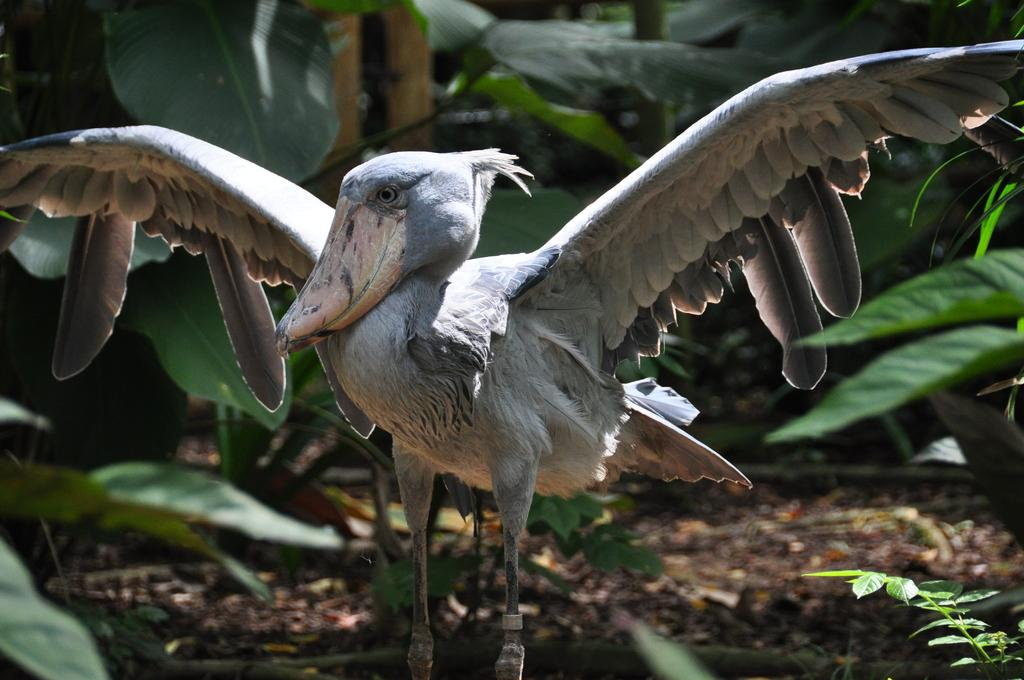What is the main subject in the middle of the image? There is a bird in the middle of the image. What can be seen in the background of the image? There are green leaves in the background of the image. What type of surface is the bird standing on? The ground contains soil. What else can be found on the ground in the image? Small stones are present on the ground. What type of tank is visible in the image? There is no tank present in the image; it features a bird, green leaves, soil, and small stones. How many teeth can be seen on the bird in the image? Birds do not have teeth, so none can be seen on the bird in the image. 